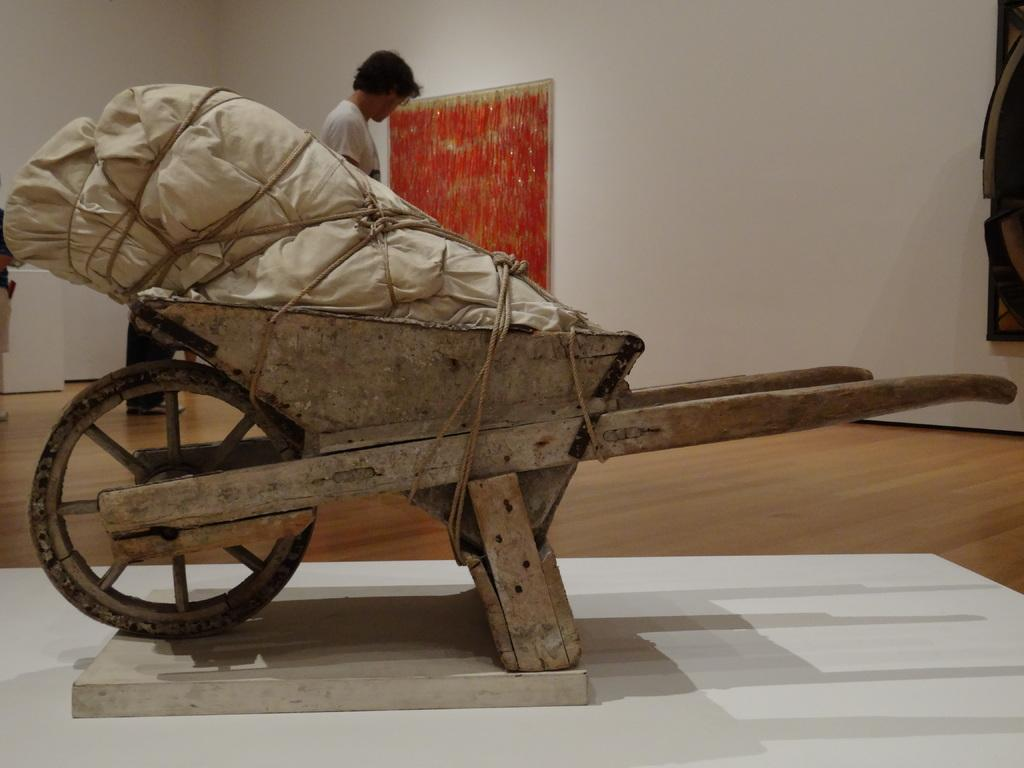What is the main object in the image? There is a wheelbarrow in the image. What is on the wheelbarrow? There is an object on the wheelbarrow. Who or what is present in the image besides the wheelbarrow? There are people in the image. What can be seen on the wall in the image? There are objects on the wall in the image. What type of soda is being served in the image? There is no soda present in the image. Is there a glove visible on the people in the image? There is no glove visible on the people in the image. 